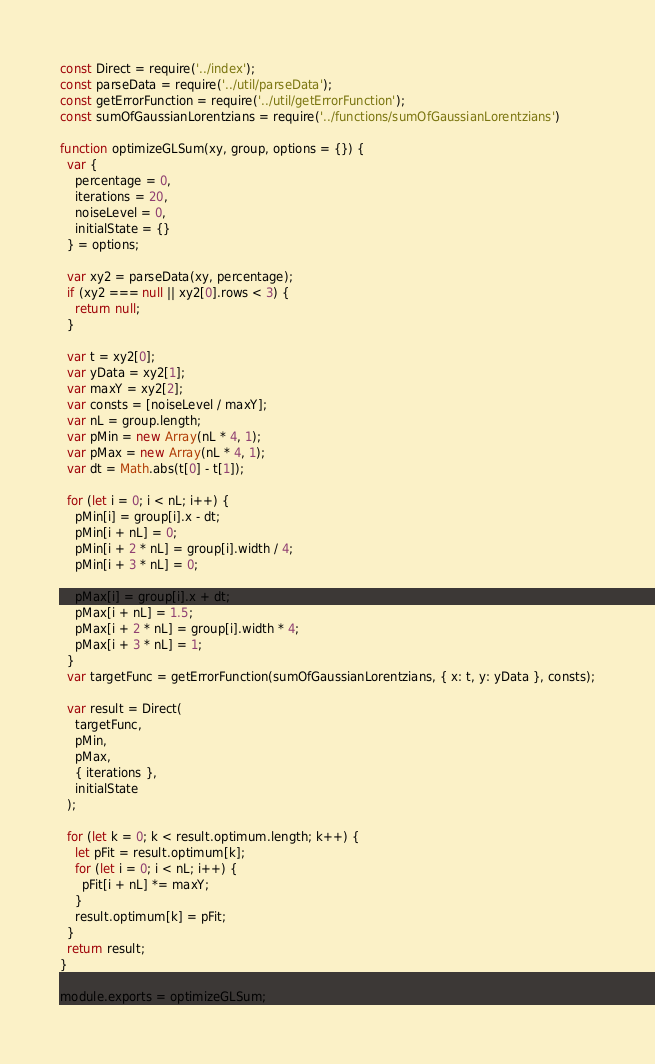Convert code to text. <code><loc_0><loc_0><loc_500><loc_500><_JavaScript_>const Direct = require('../index');
const parseData = require('../util/parseData');
const getErrorFunction = require('../util/getErrorFunction');
const sumOfGaussianLorentzians = require('../functions/sumOfGaussianLorentzians')

function optimizeGLSum(xy, group, options = {}) {
  var {
    percentage = 0,
    iterations = 20,
    noiseLevel = 0,
    initialState = {}
  } = options;

  var xy2 = parseData(xy, percentage);
  if (xy2 === null || xy2[0].rows < 3) {
    return null;
  }

  var t = xy2[0];
  var yData = xy2[1];
  var maxY = xy2[2];
  var consts = [noiseLevel / maxY];
  var nL = group.length;
  var pMin = new Array(nL * 4, 1);
  var pMax = new Array(nL * 4, 1);
  var dt = Math.abs(t[0] - t[1]);
  
  for (let i = 0; i < nL; i++) {
    pMin[i] = group[i].x - dt;
    pMin[i + nL] = 0;
    pMin[i + 2 * nL] = group[i].width / 4;
    pMin[i + 3 * nL] = 0;

    pMax[i] = group[i].x + dt;
    pMax[i + nL] = 1.5;
    pMax[i + 2 * nL] = group[i].width * 4;
    pMax[i + 3 * nL] = 1;
  }
  var targetFunc = getErrorFunction(sumOfGaussianLorentzians, { x: t, y: yData }, consts);

  var result = Direct(
    targetFunc,
    pMin,
    pMax,
    { iterations },
    initialState
  );

  for (let k = 0; k < result.optimum.length; k++) {
    let pFit = result.optimum[k];
    for (let i = 0; i < nL; i++) {
      pFit[i + nL] *= maxY;
    }
    result.optimum[k] = pFit;
  }
  return result;
}

module.exports = optimizeGLSum;</code> 